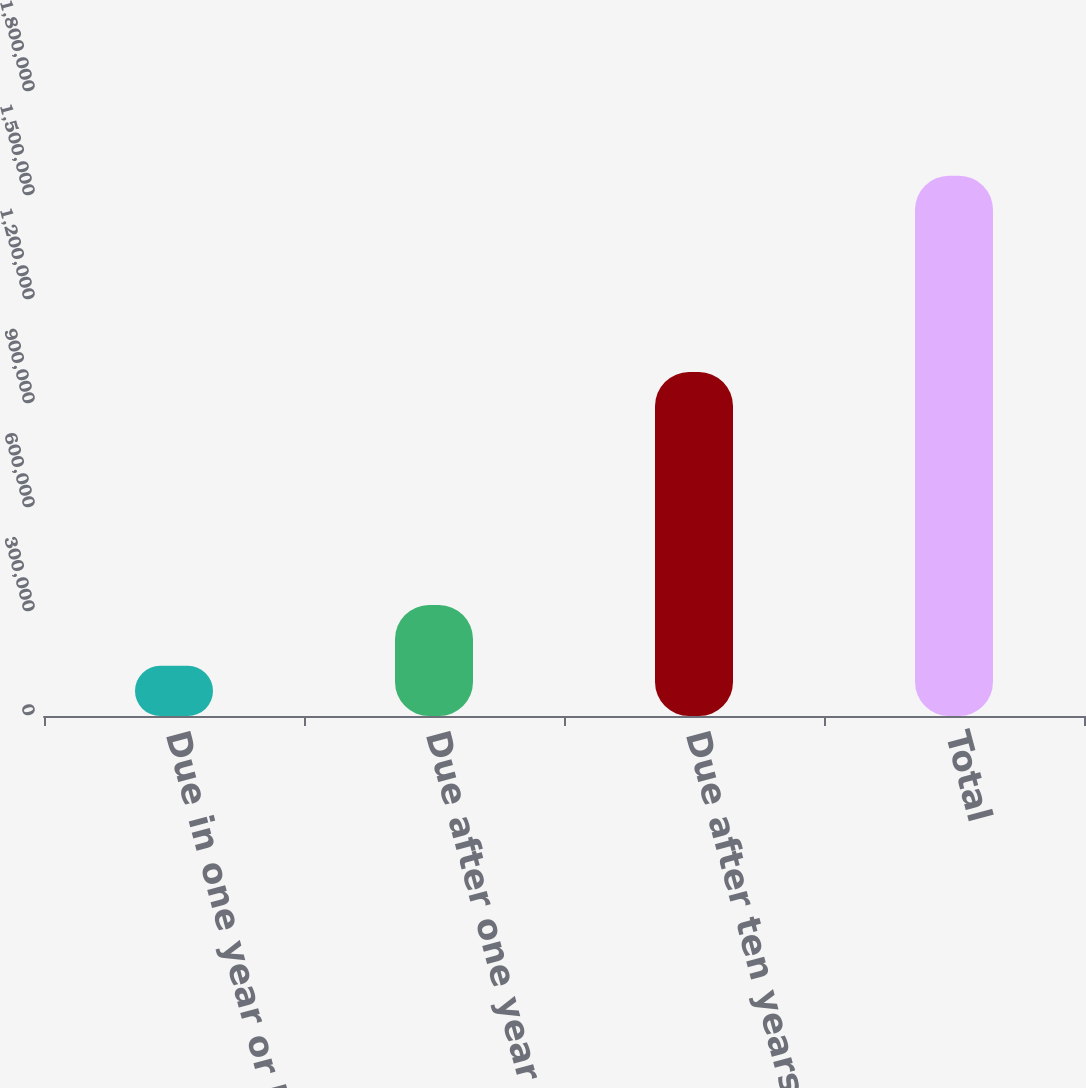Convert chart. <chart><loc_0><loc_0><loc_500><loc_500><bar_chart><fcel>Due in one year or less<fcel>Due after one year through<fcel>Due after ten years<fcel>Total<nl><fcel>144787<fcel>320067<fcel>992173<fcel>1.55833e+06<nl></chart> 